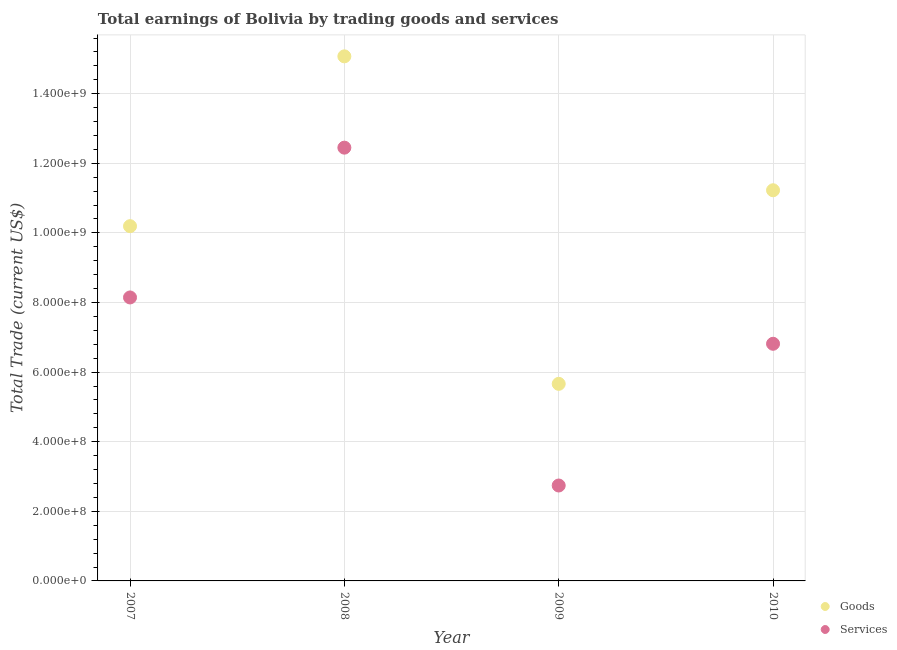How many different coloured dotlines are there?
Provide a short and direct response. 2. Is the number of dotlines equal to the number of legend labels?
Provide a short and direct response. Yes. What is the amount earned by trading goods in 2007?
Offer a very short reply. 1.02e+09. Across all years, what is the maximum amount earned by trading goods?
Make the answer very short. 1.51e+09. Across all years, what is the minimum amount earned by trading goods?
Give a very brief answer. 5.66e+08. In which year was the amount earned by trading services maximum?
Make the answer very short. 2008. In which year was the amount earned by trading services minimum?
Offer a very short reply. 2009. What is the total amount earned by trading goods in the graph?
Make the answer very short. 4.22e+09. What is the difference between the amount earned by trading goods in 2007 and that in 2009?
Offer a terse response. 4.53e+08. What is the difference between the amount earned by trading services in 2007 and the amount earned by trading goods in 2009?
Keep it short and to the point. 2.48e+08. What is the average amount earned by trading goods per year?
Your response must be concise. 1.05e+09. In the year 2007, what is the difference between the amount earned by trading goods and amount earned by trading services?
Offer a terse response. 2.05e+08. In how many years, is the amount earned by trading services greater than 1120000000 US$?
Offer a terse response. 1. What is the ratio of the amount earned by trading goods in 2008 to that in 2010?
Your answer should be compact. 1.34. What is the difference between the highest and the second highest amount earned by trading goods?
Provide a succinct answer. 3.85e+08. What is the difference between the highest and the lowest amount earned by trading services?
Provide a succinct answer. 9.71e+08. In how many years, is the amount earned by trading services greater than the average amount earned by trading services taken over all years?
Provide a succinct answer. 2. Is the amount earned by trading goods strictly greater than the amount earned by trading services over the years?
Your answer should be compact. Yes. Is the amount earned by trading goods strictly less than the amount earned by trading services over the years?
Give a very brief answer. No. How many dotlines are there?
Offer a very short reply. 2. What is the difference between two consecutive major ticks on the Y-axis?
Your answer should be very brief. 2.00e+08. Does the graph contain any zero values?
Make the answer very short. No. Where does the legend appear in the graph?
Offer a very short reply. Bottom right. How many legend labels are there?
Offer a very short reply. 2. How are the legend labels stacked?
Your answer should be very brief. Vertical. What is the title of the graph?
Your answer should be compact. Total earnings of Bolivia by trading goods and services. What is the label or title of the Y-axis?
Make the answer very short. Total Trade (current US$). What is the Total Trade (current US$) in Goods in 2007?
Your answer should be compact. 1.02e+09. What is the Total Trade (current US$) in Services in 2007?
Ensure brevity in your answer.  8.15e+08. What is the Total Trade (current US$) in Goods in 2008?
Give a very brief answer. 1.51e+09. What is the Total Trade (current US$) in Services in 2008?
Keep it short and to the point. 1.24e+09. What is the Total Trade (current US$) in Goods in 2009?
Make the answer very short. 5.66e+08. What is the Total Trade (current US$) of Services in 2009?
Provide a short and direct response. 2.74e+08. What is the Total Trade (current US$) of Goods in 2010?
Provide a short and direct response. 1.12e+09. What is the Total Trade (current US$) of Services in 2010?
Your response must be concise. 6.81e+08. Across all years, what is the maximum Total Trade (current US$) in Goods?
Make the answer very short. 1.51e+09. Across all years, what is the maximum Total Trade (current US$) in Services?
Your response must be concise. 1.24e+09. Across all years, what is the minimum Total Trade (current US$) in Goods?
Offer a very short reply. 5.66e+08. Across all years, what is the minimum Total Trade (current US$) of Services?
Your answer should be very brief. 2.74e+08. What is the total Total Trade (current US$) in Goods in the graph?
Provide a short and direct response. 4.22e+09. What is the total Total Trade (current US$) in Services in the graph?
Provide a succinct answer. 3.02e+09. What is the difference between the Total Trade (current US$) of Goods in 2007 and that in 2008?
Provide a succinct answer. -4.88e+08. What is the difference between the Total Trade (current US$) in Services in 2007 and that in 2008?
Provide a succinct answer. -4.30e+08. What is the difference between the Total Trade (current US$) of Goods in 2007 and that in 2009?
Your response must be concise. 4.53e+08. What is the difference between the Total Trade (current US$) of Services in 2007 and that in 2009?
Your answer should be very brief. 5.40e+08. What is the difference between the Total Trade (current US$) in Goods in 2007 and that in 2010?
Make the answer very short. -1.03e+08. What is the difference between the Total Trade (current US$) of Services in 2007 and that in 2010?
Offer a terse response. 1.33e+08. What is the difference between the Total Trade (current US$) of Goods in 2008 and that in 2009?
Keep it short and to the point. 9.41e+08. What is the difference between the Total Trade (current US$) of Services in 2008 and that in 2009?
Offer a very short reply. 9.71e+08. What is the difference between the Total Trade (current US$) in Goods in 2008 and that in 2010?
Ensure brevity in your answer.  3.85e+08. What is the difference between the Total Trade (current US$) of Services in 2008 and that in 2010?
Keep it short and to the point. 5.64e+08. What is the difference between the Total Trade (current US$) in Goods in 2009 and that in 2010?
Your answer should be compact. -5.56e+08. What is the difference between the Total Trade (current US$) of Services in 2009 and that in 2010?
Make the answer very short. -4.07e+08. What is the difference between the Total Trade (current US$) of Goods in 2007 and the Total Trade (current US$) of Services in 2008?
Make the answer very short. -2.26e+08. What is the difference between the Total Trade (current US$) of Goods in 2007 and the Total Trade (current US$) of Services in 2009?
Your answer should be very brief. 7.45e+08. What is the difference between the Total Trade (current US$) of Goods in 2007 and the Total Trade (current US$) of Services in 2010?
Offer a terse response. 3.38e+08. What is the difference between the Total Trade (current US$) in Goods in 2008 and the Total Trade (current US$) in Services in 2009?
Offer a very short reply. 1.23e+09. What is the difference between the Total Trade (current US$) in Goods in 2008 and the Total Trade (current US$) in Services in 2010?
Give a very brief answer. 8.26e+08. What is the difference between the Total Trade (current US$) of Goods in 2009 and the Total Trade (current US$) of Services in 2010?
Make the answer very short. -1.15e+08. What is the average Total Trade (current US$) in Goods per year?
Make the answer very short. 1.05e+09. What is the average Total Trade (current US$) in Services per year?
Your response must be concise. 7.54e+08. In the year 2007, what is the difference between the Total Trade (current US$) in Goods and Total Trade (current US$) in Services?
Provide a short and direct response. 2.05e+08. In the year 2008, what is the difference between the Total Trade (current US$) of Goods and Total Trade (current US$) of Services?
Make the answer very short. 2.62e+08. In the year 2009, what is the difference between the Total Trade (current US$) in Goods and Total Trade (current US$) in Services?
Ensure brevity in your answer.  2.92e+08. In the year 2010, what is the difference between the Total Trade (current US$) in Goods and Total Trade (current US$) in Services?
Ensure brevity in your answer.  4.41e+08. What is the ratio of the Total Trade (current US$) in Goods in 2007 to that in 2008?
Make the answer very short. 0.68. What is the ratio of the Total Trade (current US$) in Services in 2007 to that in 2008?
Provide a succinct answer. 0.65. What is the ratio of the Total Trade (current US$) of Goods in 2007 to that in 2009?
Provide a succinct answer. 1.8. What is the ratio of the Total Trade (current US$) in Services in 2007 to that in 2009?
Provide a succinct answer. 2.97. What is the ratio of the Total Trade (current US$) of Goods in 2007 to that in 2010?
Give a very brief answer. 0.91. What is the ratio of the Total Trade (current US$) in Services in 2007 to that in 2010?
Offer a terse response. 1.2. What is the ratio of the Total Trade (current US$) in Goods in 2008 to that in 2009?
Keep it short and to the point. 2.66. What is the ratio of the Total Trade (current US$) in Services in 2008 to that in 2009?
Your response must be concise. 4.54. What is the ratio of the Total Trade (current US$) in Goods in 2008 to that in 2010?
Give a very brief answer. 1.34. What is the ratio of the Total Trade (current US$) of Services in 2008 to that in 2010?
Provide a succinct answer. 1.83. What is the ratio of the Total Trade (current US$) of Goods in 2009 to that in 2010?
Provide a short and direct response. 0.5. What is the ratio of the Total Trade (current US$) of Services in 2009 to that in 2010?
Make the answer very short. 0.4. What is the difference between the highest and the second highest Total Trade (current US$) in Goods?
Make the answer very short. 3.85e+08. What is the difference between the highest and the second highest Total Trade (current US$) in Services?
Your answer should be compact. 4.30e+08. What is the difference between the highest and the lowest Total Trade (current US$) in Goods?
Make the answer very short. 9.41e+08. What is the difference between the highest and the lowest Total Trade (current US$) in Services?
Ensure brevity in your answer.  9.71e+08. 